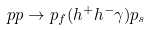<formula> <loc_0><loc_0><loc_500><loc_500>p p \rightarrow p _ { f } ( h ^ { + } h ^ { - } \gamma ) p _ { s }</formula> 